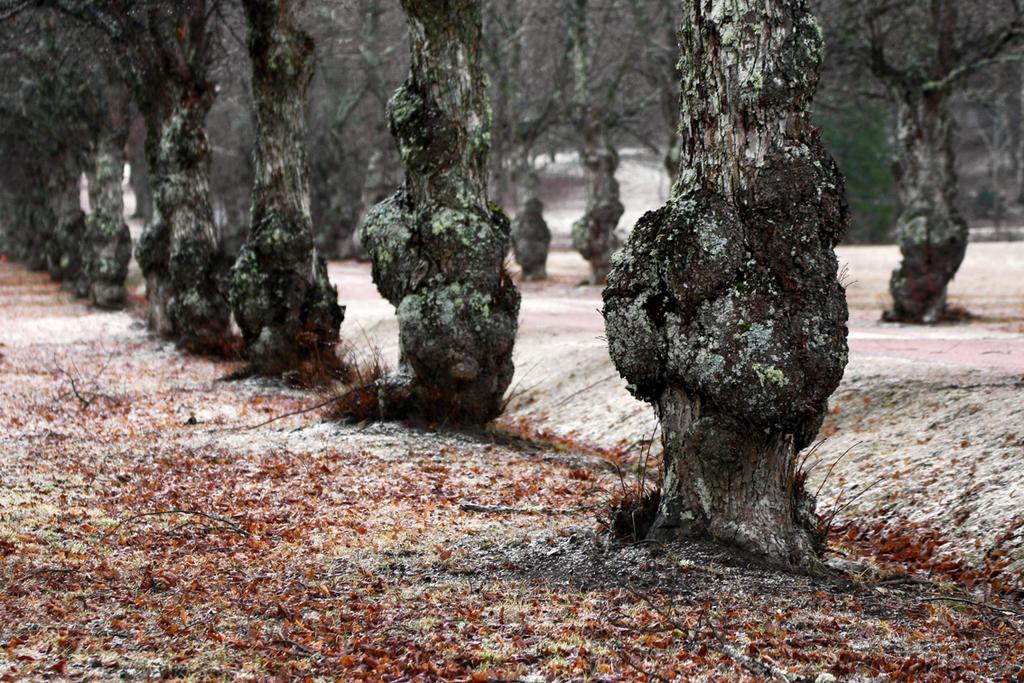Please provide a concise description of this image. In this picture we can see a few tree trunks on the path. There is a house in the background. 